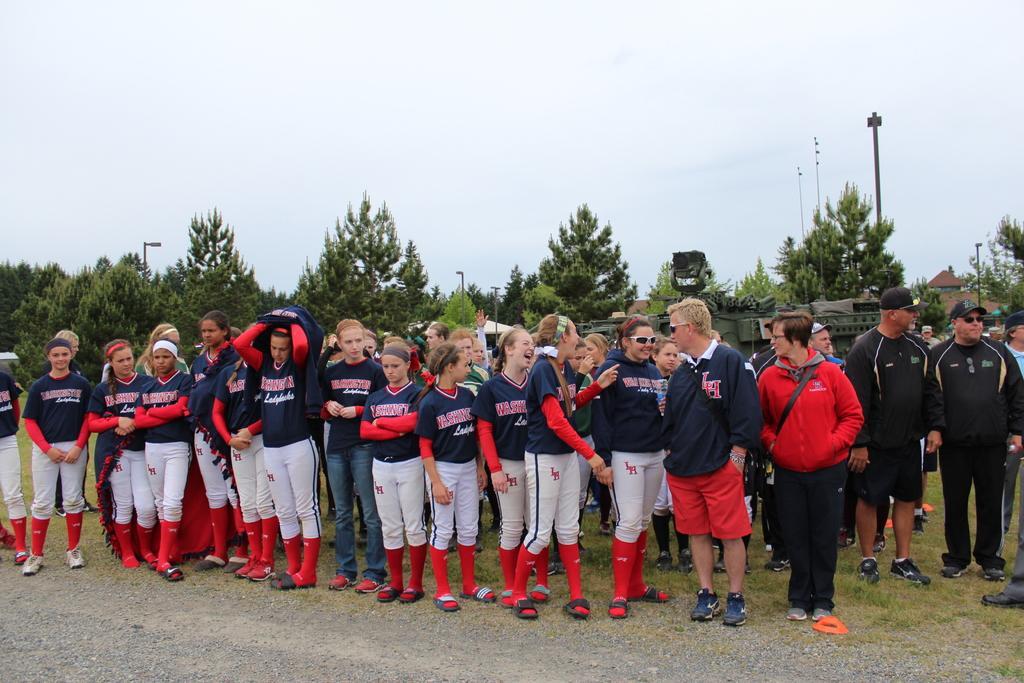Could you give a brief overview of what you see in this image? This image is taken outdoors. At the top of the image there is the sky with clouds. At the bottom of the image there is a ground with grass on it. In the background there are many trees. There are a few houses and there are a few poles with street lights. In the middle of the image many people are standing on the ground. 